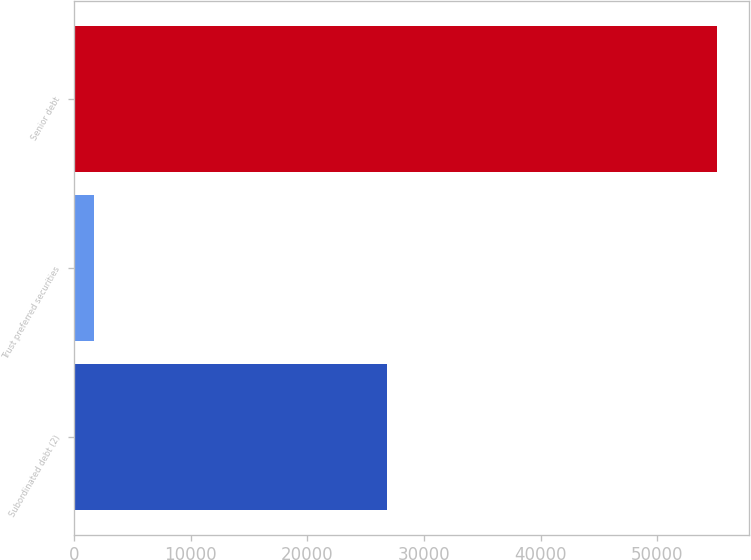Convert chart to OTSL. <chart><loc_0><loc_0><loc_500><loc_500><bar_chart><fcel>Subordinated debt (2)<fcel>Trust preferred securities<fcel>Senior debt<nl><fcel>26875<fcel>1713<fcel>55131<nl></chart> 